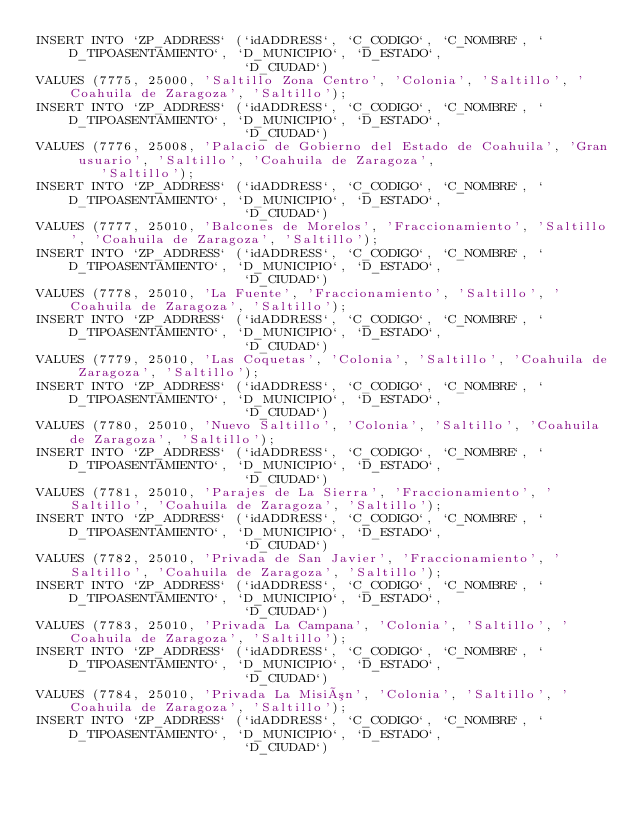<code> <loc_0><loc_0><loc_500><loc_500><_SQL_>INSERT INTO `ZP_ADDRESS` (`idADDRESS`, `C_CODIGO`, `C_NOMBRE`, `D_TIPOASENTAMIENTO`, `D_MUNICIPIO`, `D_ESTADO`,
                          `D_CIUDAD`)
VALUES (7775, 25000, 'Saltillo Zona Centro', 'Colonia', 'Saltillo', 'Coahuila de Zaragoza', 'Saltillo');
INSERT INTO `ZP_ADDRESS` (`idADDRESS`, `C_CODIGO`, `C_NOMBRE`, `D_TIPOASENTAMIENTO`, `D_MUNICIPIO`, `D_ESTADO`,
                          `D_CIUDAD`)
VALUES (7776, 25008, 'Palacio de Gobierno del Estado de Coahuila', 'Gran usuario', 'Saltillo', 'Coahuila de Zaragoza',
        'Saltillo');
INSERT INTO `ZP_ADDRESS` (`idADDRESS`, `C_CODIGO`, `C_NOMBRE`, `D_TIPOASENTAMIENTO`, `D_MUNICIPIO`, `D_ESTADO`,
                          `D_CIUDAD`)
VALUES (7777, 25010, 'Balcones de Morelos', 'Fraccionamiento', 'Saltillo', 'Coahuila de Zaragoza', 'Saltillo');
INSERT INTO `ZP_ADDRESS` (`idADDRESS`, `C_CODIGO`, `C_NOMBRE`, `D_TIPOASENTAMIENTO`, `D_MUNICIPIO`, `D_ESTADO`,
                          `D_CIUDAD`)
VALUES (7778, 25010, 'La Fuente', 'Fraccionamiento', 'Saltillo', 'Coahuila de Zaragoza', 'Saltillo');
INSERT INTO `ZP_ADDRESS` (`idADDRESS`, `C_CODIGO`, `C_NOMBRE`, `D_TIPOASENTAMIENTO`, `D_MUNICIPIO`, `D_ESTADO`,
                          `D_CIUDAD`)
VALUES (7779, 25010, 'Las Coquetas', 'Colonia', 'Saltillo', 'Coahuila de Zaragoza', 'Saltillo');
INSERT INTO `ZP_ADDRESS` (`idADDRESS`, `C_CODIGO`, `C_NOMBRE`, `D_TIPOASENTAMIENTO`, `D_MUNICIPIO`, `D_ESTADO`,
                          `D_CIUDAD`)
VALUES (7780, 25010, 'Nuevo Saltillo', 'Colonia', 'Saltillo', 'Coahuila de Zaragoza', 'Saltillo');
INSERT INTO `ZP_ADDRESS` (`idADDRESS`, `C_CODIGO`, `C_NOMBRE`, `D_TIPOASENTAMIENTO`, `D_MUNICIPIO`, `D_ESTADO`,
                          `D_CIUDAD`)
VALUES (7781, 25010, 'Parajes de La Sierra', 'Fraccionamiento', 'Saltillo', 'Coahuila de Zaragoza', 'Saltillo');
INSERT INTO `ZP_ADDRESS` (`idADDRESS`, `C_CODIGO`, `C_NOMBRE`, `D_TIPOASENTAMIENTO`, `D_MUNICIPIO`, `D_ESTADO`,
                          `D_CIUDAD`)
VALUES (7782, 25010, 'Privada de San Javier', 'Fraccionamiento', 'Saltillo', 'Coahuila de Zaragoza', 'Saltillo');
INSERT INTO `ZP_ADDRESS` (`idADDRESS`, `C_CODIGO`, `C_NOMBRE`, `D_TIPOASENTAMIENTO`, `D_MUNICIPIO`, `D_ESTADO`,
                          `D_CIUDAD`)
VALUES (7783, 25010, 'Privada La Campana', 'Colonia', 'Saltillo', 'Coahuila de Zaragoza', 'Saltillo');
INSERT INTO `ZP_ADDRESS` (`idADDRESS`, `C_CODIGO`, `C_NOMBRE`, `D_TIPOASENTAMIENTO`, `D_MUNICIPIO`, `D_ESTADO`,
                          `D_CIUDAD`)
VALUES (7784, 25010, 'Privada La Misión', 'Colonia', 'Saltillo', 'Coahuila de Zaragoza', 'Saltillo');
INSERT INTO `ZP_ADDRESS` (`idADDRESS`, `C_CODIGO`, `C_NOMBRE`, `D_TIPOASENTAMIENTO`, `D_MUNICIPIO`, `D_ESTADO`,
                          `D_CIUDAD`)</code> 